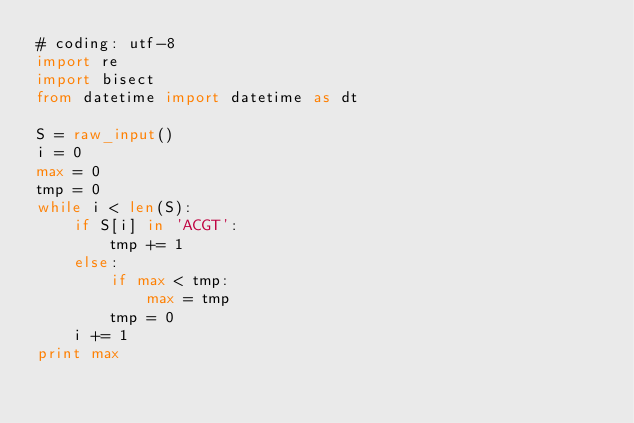Convert code to text. <code><loc_0><loc_0><loc_500><loc_500><_Python_># coding: utf-8
import re
import bisect
from datetime import datetime as dt

S = raw_input()
i = 0
max = 0
tmp = 0
while i < len(S):
    if S[i] in 'ACGT':
        tmp += 1
    else:
        if max < tmp:
            max = tmp
        tmp = 0
    i += 1
print max
        
</code> 